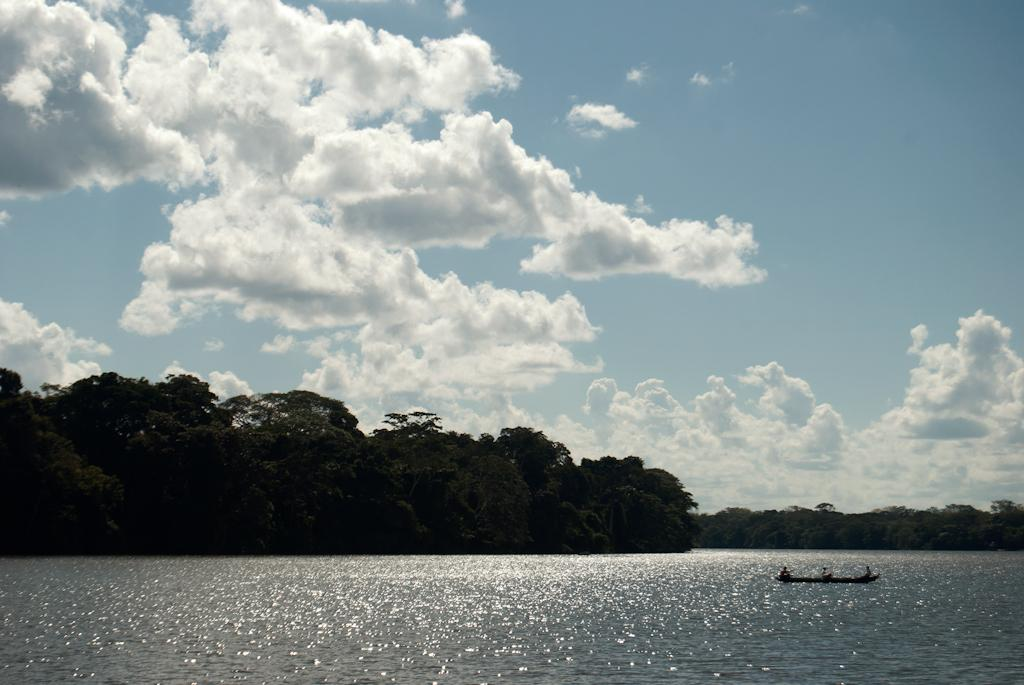What is the primary feature of the landscape in the image? There are many trees in the image. What can be seen in the sky in the image? The sky is visible with clouds in the image. What type of watercraft is present in the image? There is a boat on the surface of the river at the bottom of the image. What type of fang can be seen in the image? There are no fangs present in the image; it features trees, clouds, and a boat on a river. What animal is visible in the image? There are no animals visible in the image; it features trees, clouds, and a boat on a river. 